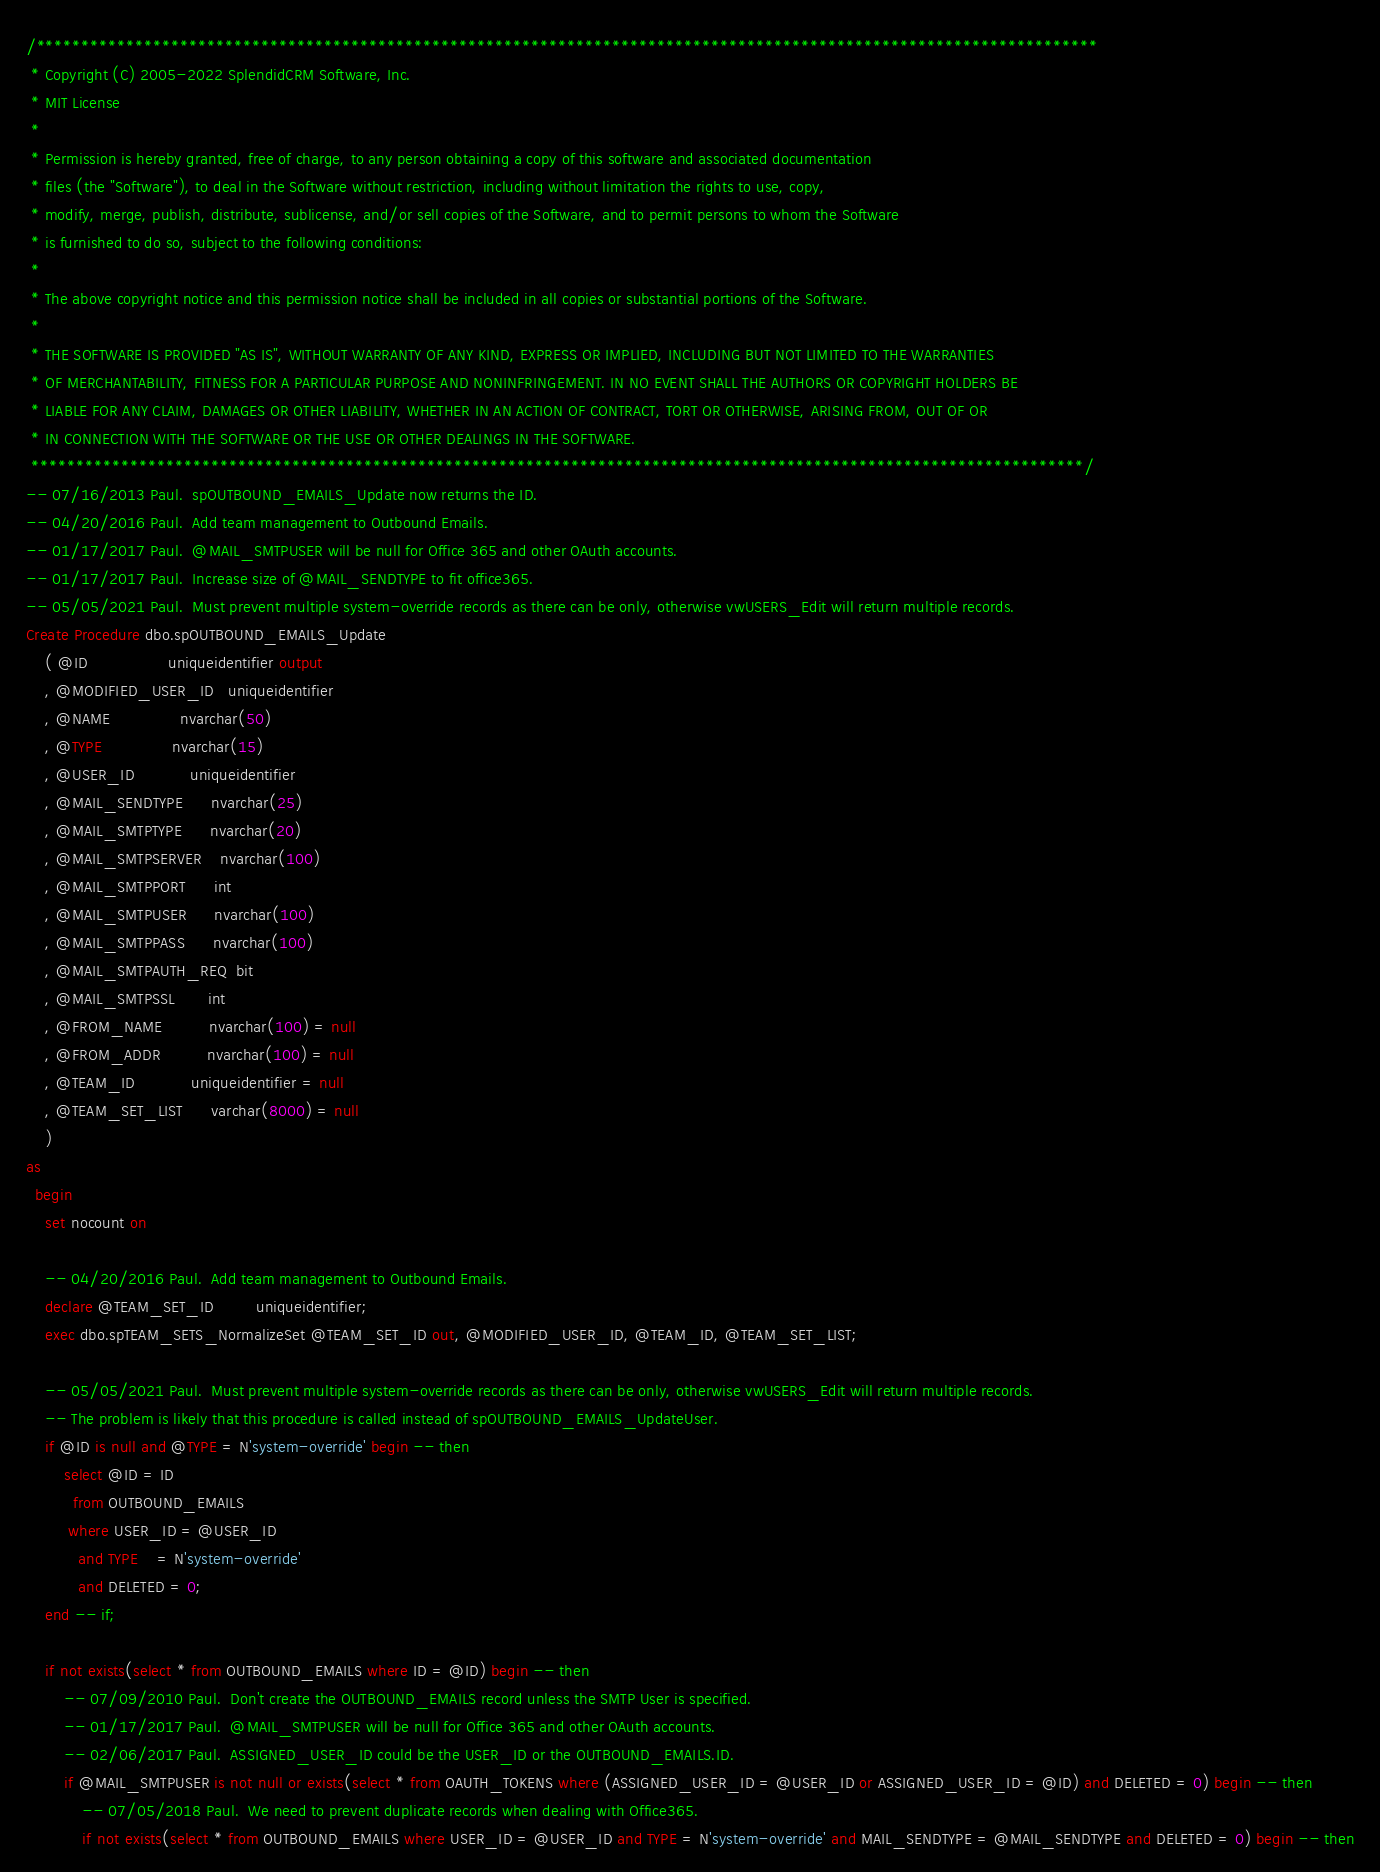Convert code to text. <code><loc_0><loc_0><loc_500><loc_500><_SQL_>/**********************************************************************************************************************
 * Copyright (C) 2005-2022 SplendidCRM Software, Inc. 
 * MIT License
 * 
 * Permission is hereby granted, free of charge, to any person obtaining a copy of this software and associated documentation 
 * files (the "Software"), to deal in the Software without restriction, including without limitation the rights to use, copy, 
 * modify, merge, publish, distribute, sublicense, and/or sell copies of the Software, and to permit persons to whom the Software 
 * is furnished to do so, subject to the following conditions:
 * 
 * The above copyright notice and this permission notice shall be included in all copies or substantial portions of the Software.
 * 
 * THE SOFTWARE IS PROVIDED "AS IS", WITHOUT WARRANTY OF ANY KIND, EXPRESS OR IMPLIED, INCLUDING BUT NOT LIMITED TO THE WARRANTIES 
 * OF MERCHANTABILITY, FITNESS FOR A PARTICULAR PURPOSE AND NONINFRINGEMENT. IN NO EVENT SHALL THE AUTHORS OR COPYRIGHT HOLDERS BE 
 * LIABLE FOR ANY CLAIM, DAMAGES OR OTHER LIABILITY, WHETHER IN AN ACTION OF CONTRACT, TORT OR OTHERWISE, ARISING FROM, OUT OF OR 
 * IN CONNECTION WITH THE SOFTWARE OR THE USE OR OTHER DEALINGS IN THE SOFTWARE.
 *********************************************************************************************************************/
-- 07/16/2013 Paul.  spOUTBOUND_EMAILS_Update now returns the ID. 
-- 04/20/2016 Paul.  Add team management to Outbound Emails. 
-- 01/17/2017 Paul.  @MAIL_SMTPUSER will be null for Office 365 and other OAuth accounts. 
-- 01/17/2017 Paul.  Increase size of @MAIL_SENDTYPE to fit office365. 
-- 05/05/2021 Paul.  Must prevent multiple system-override records as there can be only, otherwise vwUSERS_Edit will return multiple records. 
Create Procedure dbo.spOUTBOUND_EMAILS_Update
	( @ID                 uniqueidentifier output
	, @MODIFIED_USER_ID   uniqueidentifier
	, @NAME               nvarchar(50)
	, @TYPE               nvarchar(15)
	, @USER_ID            uniqueidentifier
	, @MAIL_SENDTYPE      nvarchar(25)
	, @MAIL_SMTPTYPE      nvarchar(20)
	, @MAIL_SMTPSERVER    nvarchar(100)
	, @MAIL_SMTPPORT      int
	, @MAIL_SMTPUSER      nvarchar(100)
	, @MAIL_SMTPPASS      nvarchar(100)
	, @MAIL_SMTPAUTH_REQ  bit
	, @MAIL_SMTPSSL       int
	, @FROM_NAME          nvarchar(100) = null
	, @FROM_ADDR          nvarchar(100) = null
	, @TEAM_ID            uniqueidentifier = null
	, @TEAM_SET_LIST      varchar(8000) = null
	)
as
  begin
	set nocount on
	
	-- 04/20/2016 Paul.  Add team management to Outbound Emails. 
	declare @TEAM_SET_ID         uniqueidentifier;
	exec dbo.spTEAM_SETS_NormalizeSet @TEAM_SET_ID out, @MODIFIED_USER_ID, @TEAM_ID, @TEAM_SET_LIST;

	-- 05/05/2021 Paul.  Must prevent multiple system-override records as there can be only, otherwise vwUSERS_Edit will return multiple records. 
	-- The problem is likely that this procedure is called instead of spOUTBOUND_EMAILS_UpdateUser. 
	if @ID is null and @TYPE = N'system-override' begin -- then
		select @ID = ID
		  from OUTBOUND_EMAILS
		 where USER_ID = @USER_ID 
		   and TYPE    = N'system-override'
		   and DELETED = 0;
	end -- if;

	if not exists(select * from OUTBOUND_EMAILS where ID = @ID) begin -- then
		-- 07/09/2010 Paul.  Don't create the OUTBOUND_EMAILS record unless the SMTP User is specified. 
		-- 01/17/2017 Paul.  @MAIL_SMTPUSER will be null for Office 365 and other OAuth accounts. 
		-- 02/06/2017 Paul.  ASSIGNED_USER_ID could be the USER_ID or the OUTBOUND_EMAILS.ID. 
		if @MAIL_SMTPUSER is not null or exists(select * from OAUTH_TOKENS where (ASSIGNED_USER_ID = @USER_ID or ASSIGNED_USER_ID = @ID) and DELETED = 0) begin -- then
			-- 07/05/2018 Paul.  We need to prevent duplicate records when dealing with Office365. 
			if not exists(select * from OUTBOUND_EMAILS where USER_ID = @USER_ID and TYPE = N'system-override' and MAIL_SENDTYPE = @MAIL_SENDTYPE and DELETED = 0) begin -- then</code> 